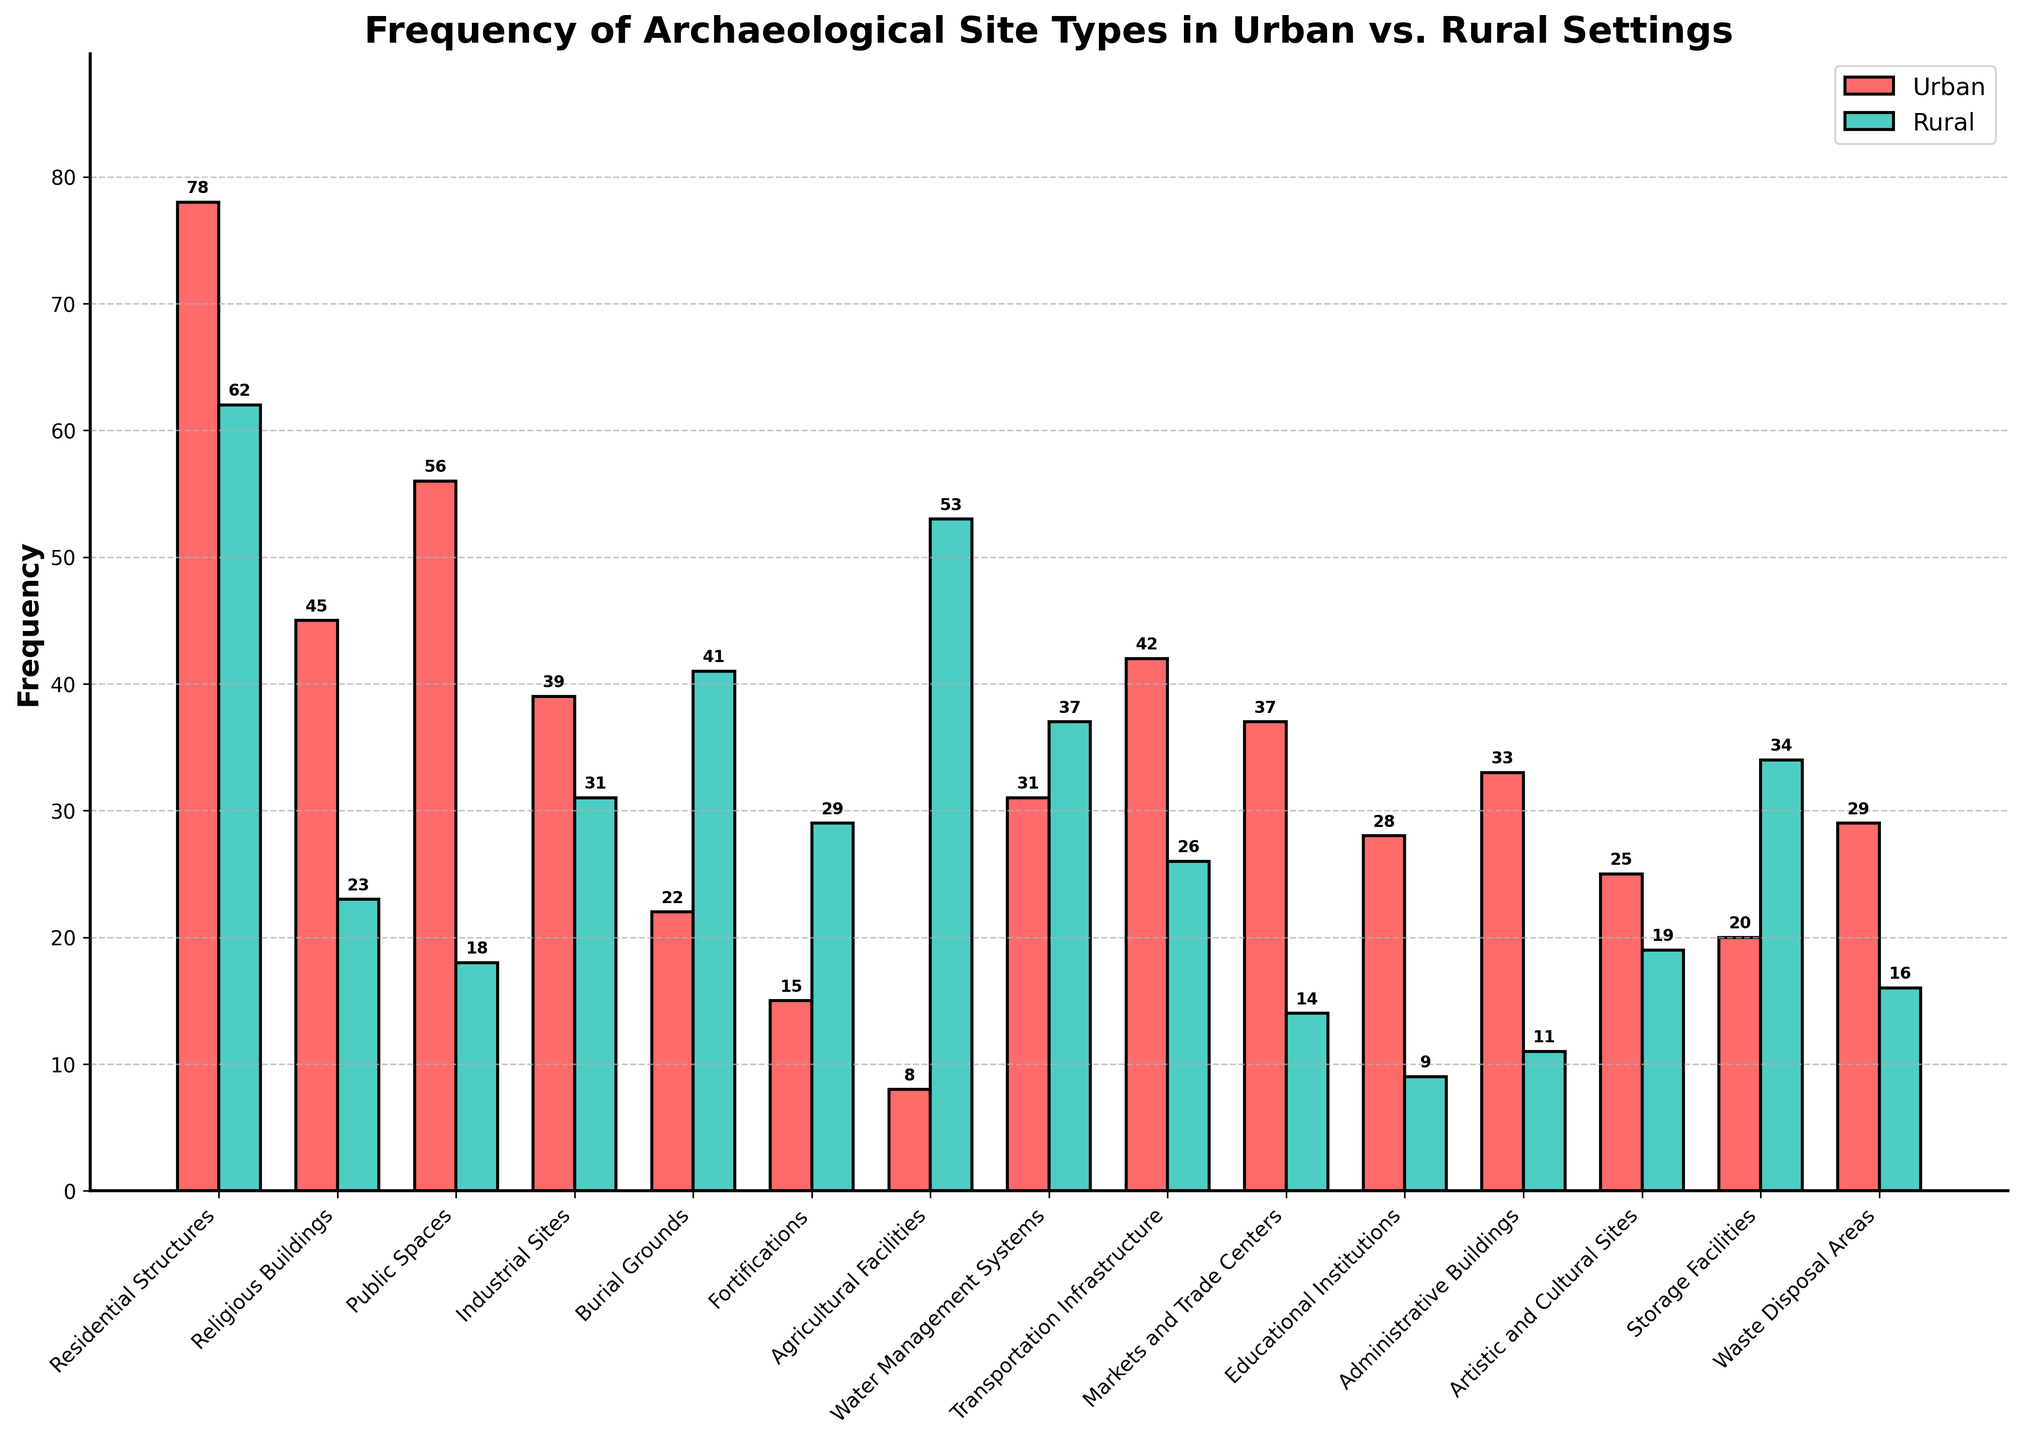What's the total frequency of Residential Structures in both urban and rural settings? To find the total frequency of Residential Structures, sum the Urban Frequency (78) and the Rural Frequency (62). Therefore, 78 + 62 = 140.
Answer: 140 Which site type is more prevalent in urban settings compared to rural settings? By visually comparing the bar heights for each site type, Residential Structures (78 urban vs. 62 rural), Religious Buildings (45 urban vs. 23 rural), Public Spaces (56 urban vs. 18 rural), Transportation Infrastructure (42 urban vs. 26 rural), Markets and Trade Centers (37 urban vs. 14 rural), Educational Institutions (28 urban vs. 9 rural), and Administrative Buildings (33 urban vs. 11 rural) are more prevalent in urban settings. Let's pick one with the most significant difference for comparison. Focus on Public Spaces, as it shows a sharp contrast.
Answer: Public Spaces What is the combined frequency of Burial Grounds and Fortifications in rural settings? Sum the rural frequencies for Burial Grounds (41) and Fortifications (29). Therefore, 41 + 29 = 70.
Answer: 70 Which category has a higher frequency of sites in rural settings compared to urban settings? Identify the categories where rural frequency bars are taller than urban frequency bars: Burial Grounds (41 rural vs. 22 urban), Fortifications (29 rural vs. 15 urban), Agricultural Facilities (53 rural vs. 8 urban), Storage Facilities (34 rural vs. 20 urban). A notable category is Agricultural Facilities.
Answer: Agricultural Facilities Which color represents urban frequencies in the bar chart? The urban bars are visually distinct; they are colored distinguishably from rural bars. The urban bars are red.
Answer: Red What is the frequency difference between Urban and Rural Transportation Infrastructure sites? Subtract the Rural Frequency (26) from the Urban Frequency (42) for Transportation Infrastructure sites. Therefore, 42 - 26 = 16.
Answer: 16 Are there any site types where the rural frequency is exactly double the urban frequency? Check the rural and urban frequencies to see if any meet the condition (2 * urban = rural). For Burial Grounds, 2 * 22 is not equal to 41; for Agricultural Facilities, 2 * 8 = 16, and so on. Review shows that no such specific condition matches perfectly.
Answer: No What is the average frequency of Market and Trade Centers in both settings combined? Add Urban Frequency (37) and Rural Frequency (14) and then divide by 2. Therefore, (37 + 14) / 2 = 25.5.
Answer: 25.5 